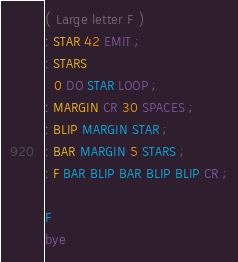Convert code to text. <code><loc_0><loc_0><loc_500><loc_500><_Forth_>( Large letter F )
: STAR 42 EMIT ;
: STARS
  0 DO STAR LOOP ;
: MARGIN CR 30 SPACES ;
: BLIP MARGIN STAR ;
: BAR MARGIN 5 STARS ;
: F BAR BLIP BAR BLIP BLIP CR ;

F
bye


</code> 